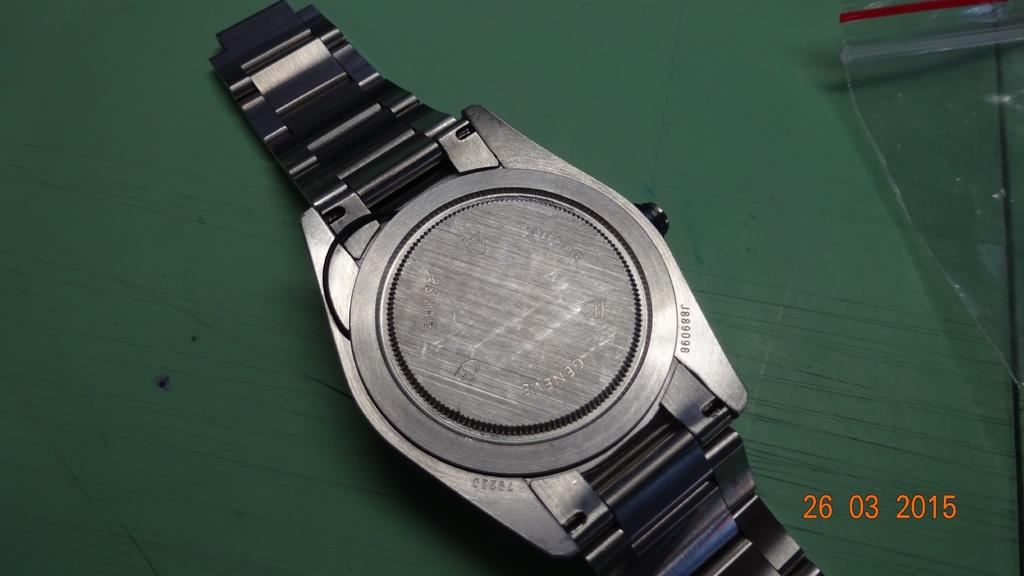What is the year date on the right?
Ensure brevity in your answer.  2015. 